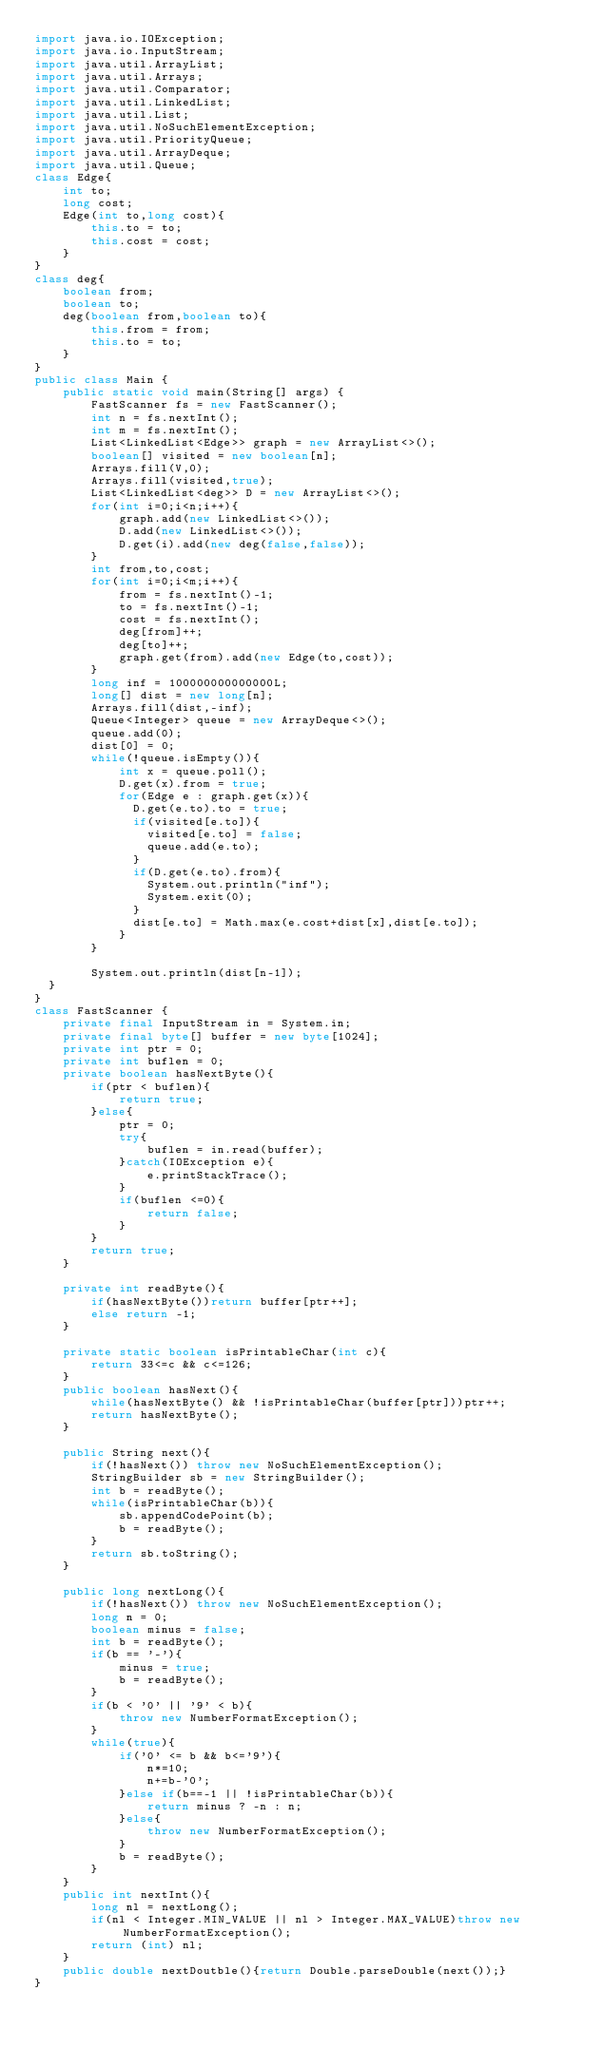<code> <loc_0><loc_0><loc_500><loc_500><_Java_>import java.io.IOException;
import java.io.InputStream;
import java.util.ArrayList;
import java.util.Arrays;
import java.util.Comparator;
import java.util.LinkedList;
import java.util.List;
import java.util.NoSuchElementException;
import java.util.PriorityQueue;
import java.util.ArrayDeque;
import java.util.Queue;
class Edge{
    int to;
    long cost;
    Edge(int to,long cost){
        this.to = to;
        this.cost = cost;
    }
}
class deg{
    boolean from;
    boolean to;
    deg(boolean from,boolean to){
        this.from = from;
        this.to = to;
    }
}
public class Main {
    public static void main(String[] args) {
        FastScanner fs = new FastScanner();
        int n = fs.nextInt();
        int m = fs.nextInt();
        List<LinkedList<Edge>> graph = new ArrayList<>();
        boolean[] visited = new boolean[n];
        Arrays.fill(V,0);
        Arrays.fill(visited,true);
        List<LinkedList<deg>> D = new ArrayList<>();
        for(int i=0;i<n;i++){
            graph.add(new LinkedList<>());
            D.add(new LinkedList<>());
            D.get(i).add(new deg(false,false));
        }
        int from,to,cost;
        for(int i=0;i<m;i++){
            from = fs.nextInt()-1;
            to = fs.nextInt()-1;
            cost = fs.nextInt();
            deg[from]++;
            deg[to]++;
            graph.get(from).add(new Edge(to,cost));
        }
        long inf = 100000000000000L;
        long[] dist = new long[n];
        Arrays.fill(dist,-inf);
        Queue<Integer> queue = new ArrayDeque<>();
        queue.add(0);
        dist[0] = 0;
        while(!queue.isEmpty()){
            int x = queue.poll();
            D.get(x).from = true;
            for(Edge e : graph.get(x)){
              D.get(e.to).to = true;
              if(visited[e.to]){
                visited[e.to] = false;
                queue.add(e.to);
              }
              if(D.get(e.to).from){
                System.out.println("inf");
                System.exit(0);
              }
              dist[e.to] = Math.max(e.cost+dist[x],dist[e.to]);
            }  
        }
      
        System.out.println(dist[n-1]);
  }
}
class FastScanner {
    private final InputStream in = System.in;
    private final byte[] buffer = new byte[1024];
    private int ptr = 0;
    private int buflen = 0;
    private boolean hasNextByte(){
        if(ptr < buflen){
            return true;
        }else{
            ptr = 0;
            try{
                buflen = in.read(buffer);
            }catch(IOException e){
                e.printStackTrace();
            }
            if(buflen <=0){
                return false;
            }
        }
        return true;
    }
 
    private int readByte(){
        if(hasNextByte())return buffer[ptr++];
        else return -1;
    }
 
    private static boolean isPrintableChar(int c){
        return 33<=c && c<=126;
    }
    public boolean hasNext(){
        while(hasNextByte() && !isPrintableChar(buffer[ptr]))ptr++;
        return hasNextByte();
    }
 
    public String next(){
        if(!hasNext()) throw new NoSuchElementException();
        StringBuilder sb = new StringBuilder();
        int b = readByte();
        while(isPrintableChar(b)){
            sb.appendCodePoint(b);
            b = readByte();
        }
        return sb.toString();
    }
 
    public long nextLong(){
        if(!hasNext()) throw new NoSuchElementException();
        long n = 0;
        boolean minus = false;
        int b = readByte();
        if(b == '-'){
            minus = true;
            b = readByte();
        }
        if(b < '0' || '9' < b){
            throw new NumberFormatException();
        }
        while(true){
            if('0' <= b && b<='9'){
                n*=10;
                n+=b-'0';
            }else if(b==-1 || !isPrintableChar(b)){
                return minus ? -n : n;
            }else{
                throw new NumberFormatException();
            }
            b = readByte();
        }
    }
    public int nextInt(){
        long nl = nextLong();
        if(nl < Integer.MIN_VALUE || nl > Integer.MAX_VALUE)throw new NumberFormatException();
        return (int) nl;
    }
    public double nextDoutble(){return Double.parseDouble(next());}
}</code> 